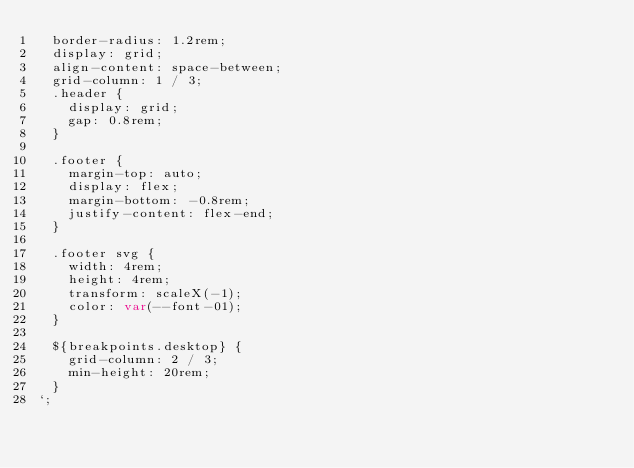<code> <loc_0><loc_0><loc_500><loc_500><_TypeScript_>  border-radius: 1.2rem;
  display: grid;
  align-content: space-between;
  grid-column: 1 / 3;
  .header {
    display: grid;
    gap: 0.8rem;
  }

  .footer {
    margin-top: auto;
    display: flex;
    margin-bottom: -0.8rem;
    justify-content: flex-end;
  }

  .footer svg {
    width: 4rem;
    height: 4rem;
    transform: scaleX(-1);
    color: var(--font-01);
  }

  ${breakpoints.desktop} {
    grid-column: 2 / 3;
    min-height: 20rem;
  }
`;
</code> 